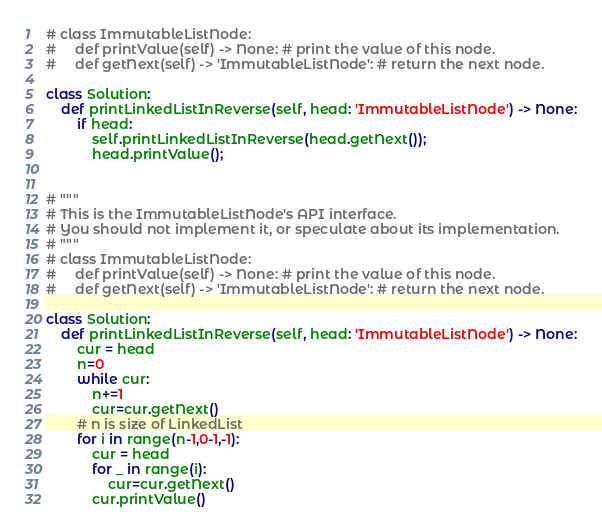<code> <loc_0><loc_0><loc_500><loc_500><_Python_># class ImmutableListNode:
#     def printValue(self) -> None: # print the value of this node.
#     def getNext(self) -> 'ImmutableListNode': # return the next node.

class Solution:
    def printLinkedListInReverse(self, head: 'ImmutableListNode') -> None:
        if head:
            self.printLinkedListInReverse(head.getNext());
            head.printValue();


# """
# This is the ImmutableListNode's API interface.
# You should not implement it, or speculate about its implementation.
# """
# class ImmutableListNode:
#     def printValue(self) -> None: # print the value of this node.
#     def getNext(self) -> 'ImmutableListNode': # return the next node.

class Solution:
    def printLinkedListInReverse(self, head: 'ImmutableListNode') -> None:
        cur = head
        n=0
        while cur:
            n+=1
            cur=cur.getNext()
        # n is size of LinkedList
        for i in range(n-1,0-1,-1):
            cur = head
            for _ in range(i):
                cur=cur.getNext()
            cur.printValue()</code> 